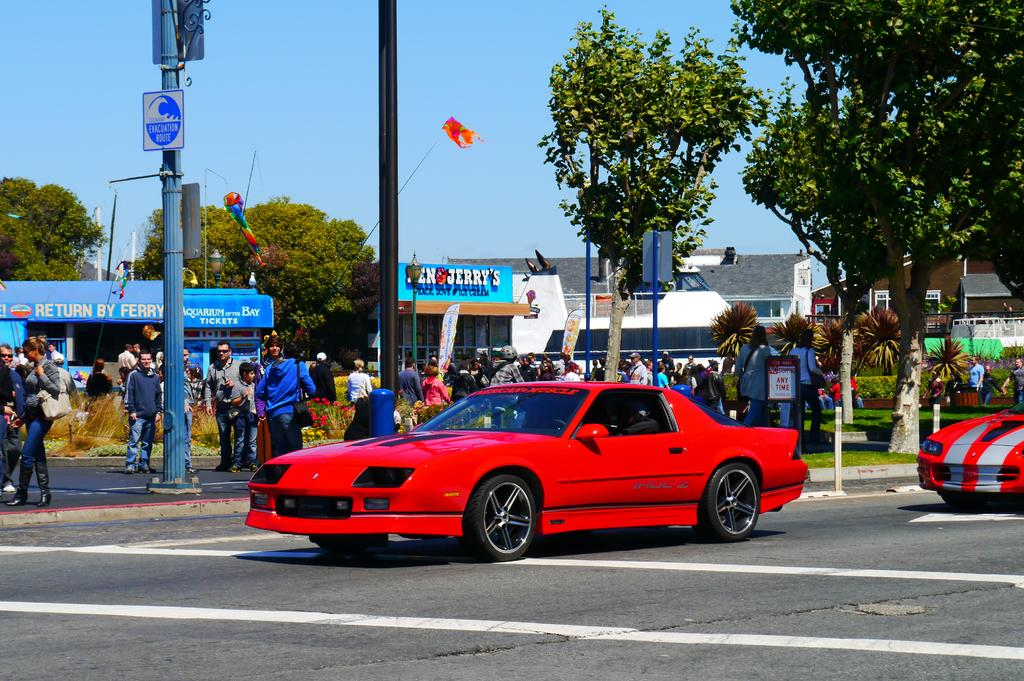What type of vehicles can be seen on the road in the image? There are cars on the road in the image. What are the people near the road doing? People are standing beside the road. What structures can be seen in the image? There are electrical poles and buildings in the image. What type of natural elements are present in the image? Trees are present in the image. Can you see any signs of regret on the faces of the people standing beside the road? There is no indication of regret on the faces of the people in the image, as the image does not show their facial expressions. What type of nail is being used to hold the electrical pole in place? There is no nail visible in the image, as the electrical poles are supported by their bases and not by nails. 